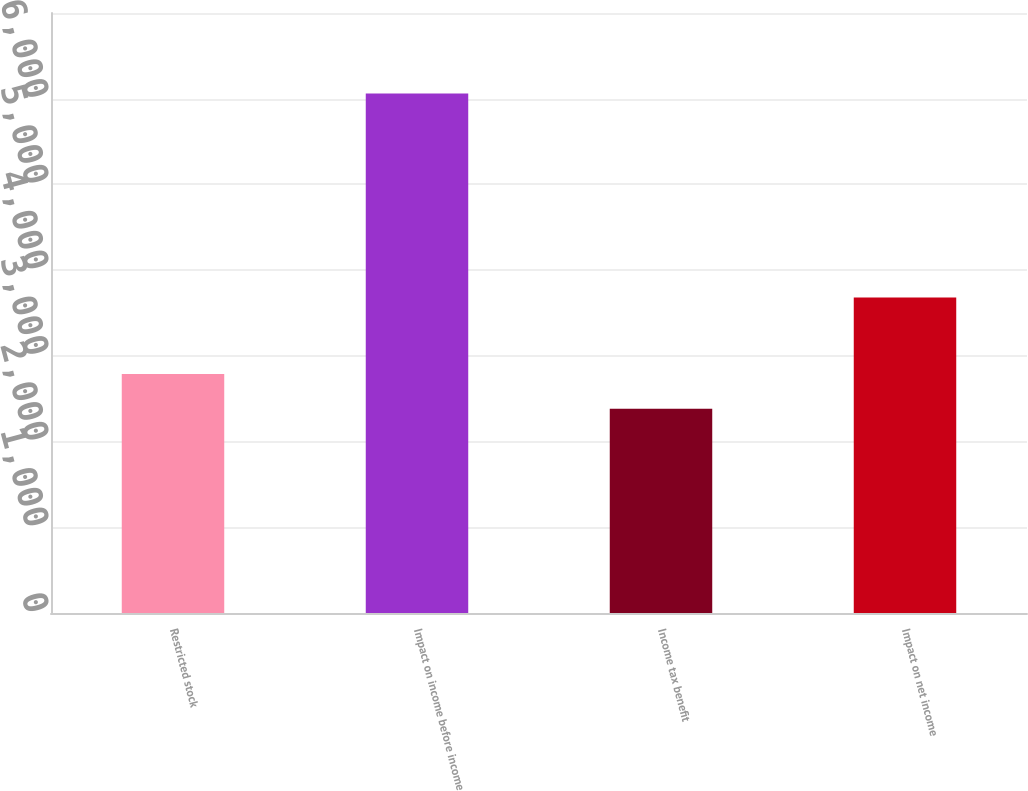Convert chart to OTSL. <chart><loc_0><loc_0><loc_500><loc_500><bar_chart><fcel>Restricted stock<fcel>Impact on income before income<fcel>Income tax benefit<fcel>Impact on net income<nl><fcel>2789<fcel>6062<fcel>2382<fcel>3680<nl></chart> 